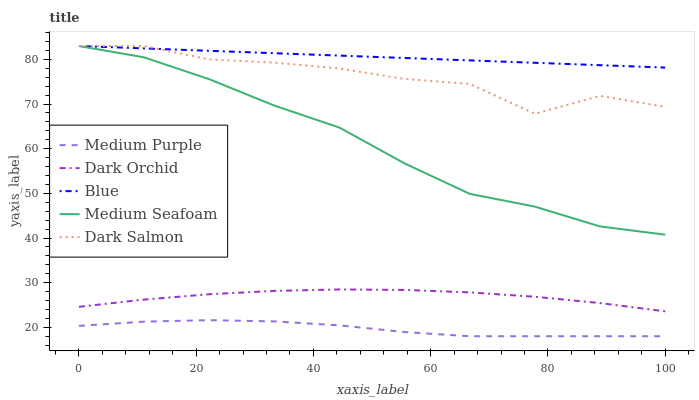Does Medium Purple have the minimum area under the curve?
Answer yes or no. Yes. Does Blue have the maximum area under the curve?
Answer yes or no. Yes. Does Medium Seafoam have the minimum area under the curve?
Answer yes or no. No. Does Medium Seafoam have the maximum area under the curve?
Answer yes or no. No. Is Blue the smoothest?
Answer yes or no. Yes. Is Dark Salmon the roughest?
Answer yes or no. Yes. Is Medium Seafoam the smoothest?
Answer yes or no. No. Is Medium Seafoam the roughest?
Answer yes or no. No. Does Medium Seafoam have the lowest value?
Answer yes or no. No. Does Dark Salmon have the highest value?
Answer yes or no. Yes. Does Dark Orchid have the highest value?
Answer yes or no. No. Is Medium Purple less than Blue?
Answer yes or no. Yes. Is Dark Salmon greater than Medium Purple?
Answer yes or no. Yes. Does Dark Salmon intersect Medium Seafoam?
Answer yes or no. Yes. Is Dark Salmon less than Medium Seafoam?
Answer yes or no. No. Is Dark Salmon greater than Medium Seafoam?
Answer yes or no. No. Does Medium Purple intersect Blue?
Answer yes or no. No. 